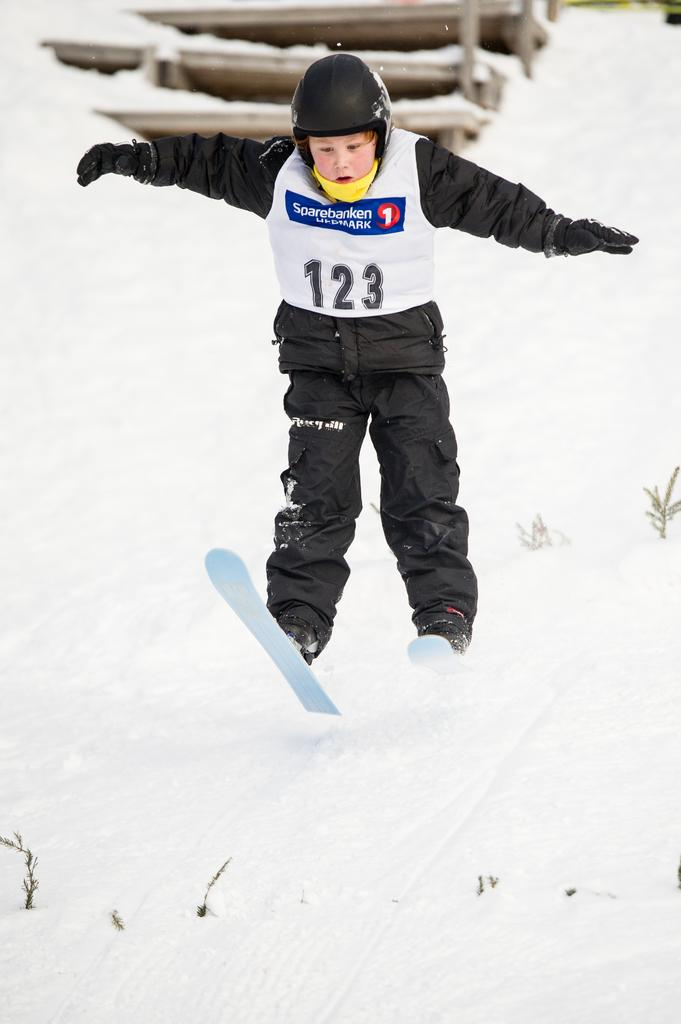Who is in the image? There is a boy in the image. What is the boy standing on? The boy is on the snow. What can be seen in the background of the image? There is a wooden staircase in the background of the image. What type of cable is the boy holding in the image? There is no cable present in the image; the boy is simply standing on the snow. 